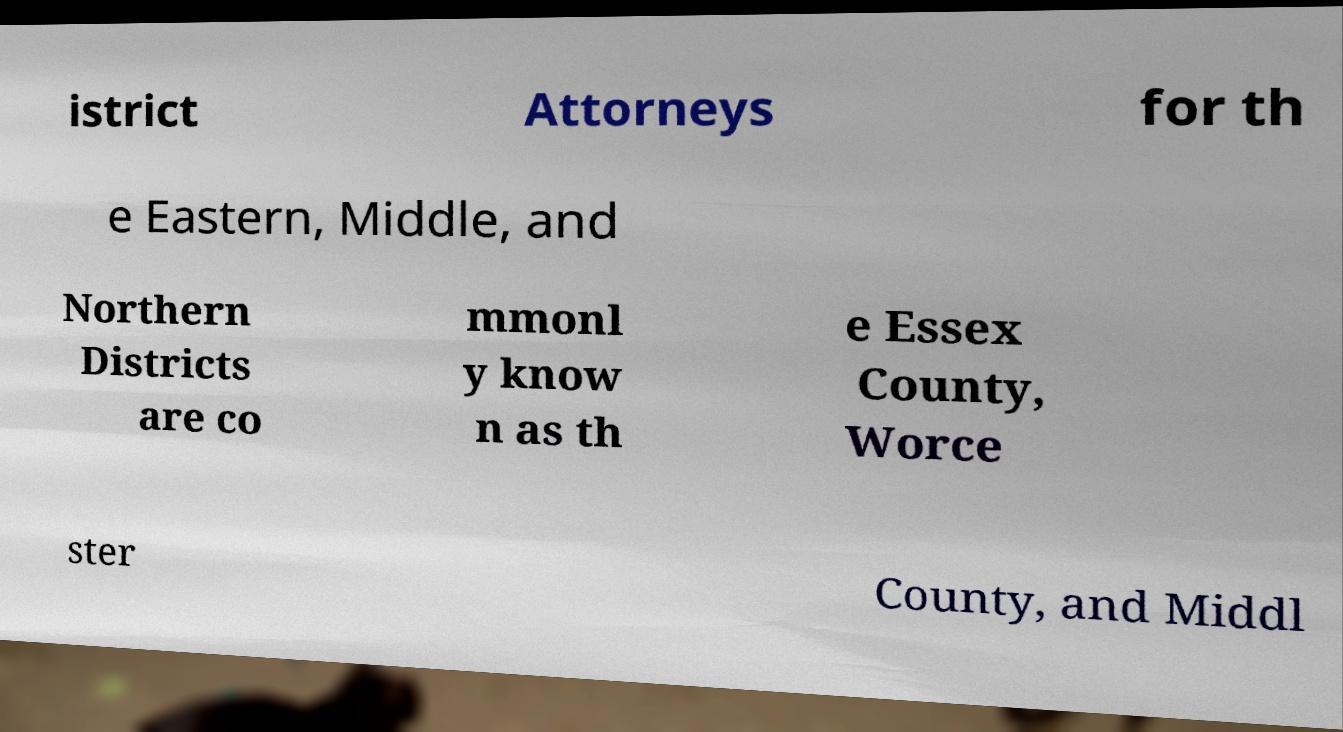For documentation purposes, I need the text within this image transcribed. Could you provide that? istrict Attorneys for th e Eastern, Middle, and Northern Districts are co mmonl y know n as th e Essex County, Worce ster County, and Middl 